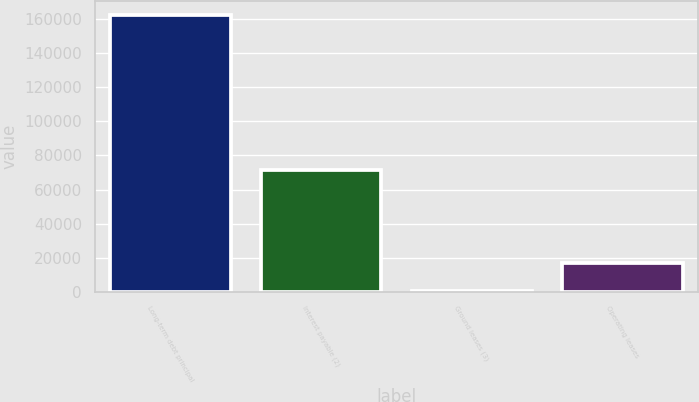Convert chart. <chart><loc_0><loc_0><loc_500><loc_500><bar_chart><fcel>Long-term debt principal<fcel>Interest payable (2)<fcel>Ground leases (3)<fcel>Operating leases<nl><fcel>162678<fcel>71738<fcel>529<fcel>16743.9<nl></chart> 